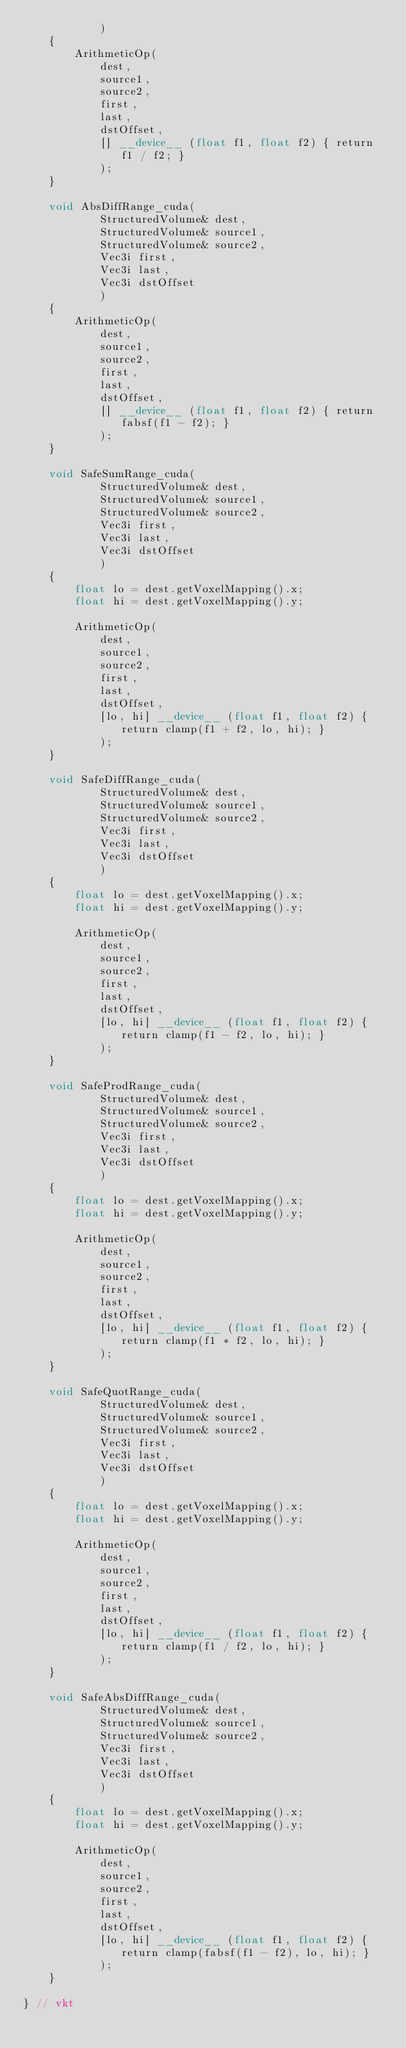Convert code to text. <code><loc_0><loc_0><loc_500><loc_500><_Cuda_>            )
    {
        ArithmeticOp(
            dest,
            source1,
            source2,
            first,
            last,
            dstOffset,
            [] __device__ (float f1, float f2) { return f1 / f2; }
            );
    }

    void AbsDiffRange_cuda(
            StructuredVolume& dest,
            StructuredVolume& source1,
            StructuredVolume& source2,
            Vec3i first,
            Vec3i last,
            Vec3i dstOffset
            )
    {
        ArithmeticOp(
            dest,
            source1,
            source2,
            first,
            last,
            dstOffset,
            [] __device__ (float f1, float f2) { return fabsf(f1 - f2); }
            );
    }

    void SafeSumRange_cuda(
            StructuredVolume& dest,
            StructuredVolume& source1,
            StructuredVolume& source2,
            Vec3i first,
            Vec3i last,
            Vec3i dstOffset
            )
    {
        float lo = dest.getVoxelMapping().x;
        float hi = dest.getVoxelMapping().y;

        ArithmeticOp(
            dest,
            source1,
            source2,
            first,
            last,
            dstOffset,
            [lo, hi] __device__ (float f1, float f2) { return clamp(f1 + f2, lo, hi); }
            );
    }

    void SafeDiffRange_cuda(
            StructuredVolume& dest,
            StructuredVolume& source1,
            StructuredVolume& source2,
            Vec3i first,
            Vec3i last,
            Vec3i dstOffset
            )
    {
        float lo = dest.getVoxelMapping().x;
        float hi = dest.getVoxelMapping().y;

        ArithmeticOp(
            dest,
            source1,
            source2,
            first,
            last,
            dstOffset,
            [lo, hi] __device__ (float f1, float f2) { return clamp(f1 - f2, lo, hi); }
            );
    }

    void SafeProdRange_cuda(
            StructuredVolume& dest,
            StructuredVolume& source1,
            StructuredVolume& source2,
            Vec3i first,
            Vec3i last,
            Vec3i dstOffset
            )
    {
        float lo = dest.getVoxelMapping().x;
        float hi = dest.getVoxelMapping().y;

        ArithmeticOp(
            dest,
            source1,
            source2,
            first,
            last,
            dstOffset,
            [lo, hi] __device__ (float f1, float f2) { return clamp(f1 * f2, lo, hi); }
            );
    }

    void SafeQuotRange_cuda(
            StructuredVolume& dest,
            StructuredVolume& source1,
            StructuredVolume& source2,
            Vec3i first,
            Vec3i last,
            Vec3i dstOffset
            )
    {
        float lo = dest.getVoxelMapping().x;
        float hi = dest.getVoxelMapping().y;

        ArithmeticOp(
            dest,
            source1,
            source2,
            first,
            last,
            dstOffset,
            [lo, hi] __device__ (float f1, float f2) { return clamp(f1 / f2, lo, hi); }
            );
    }

    void SafeAbsDiffRange_cuda(
            StructuredVolume& dest,
            StructuredVolume& source1,
            StructuredVolume& source2,
            Vec3i first,
            Vec3i last,
            Vec3i dstOffset
            )
    {
        float lo = dest.getVoxelMapping().x;
        float hi = dest.getVoxelMapping().y;

        ArithmeticOp(
            dest,
            source1,
            source2,
            first,
            last,
            dstOffset,
            [lo, hi] __device__ (float f1, float f2) { return clamp(fabsf(f1 - f2), lo, hi); }
            );
    }

} // vkt
</code> 